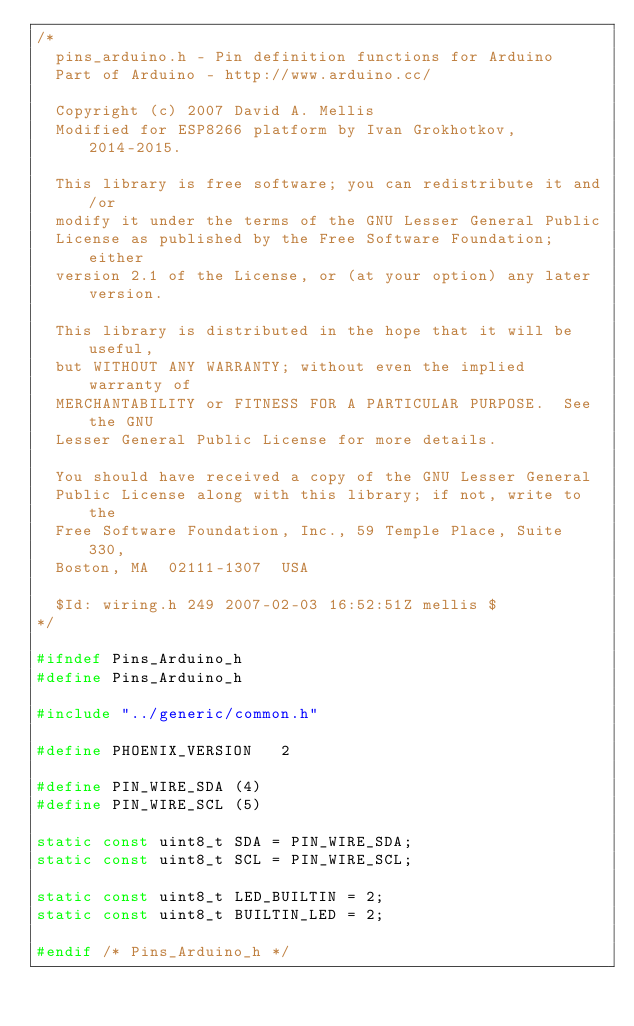Convert code to text. <code><loc_0><loc_0><loc_500><loc_500><_C_>/*
  pins_arduino.h - Pin definition functions for Arduino
  Part of Arduino - http://www.arduino.cc/

  Copyright (c) 2007 David A. Mellis
  Modified for ESP8266 platform by Ivan Grokhotkov, 2014-2015.

  This library is free software; you can redistribute it and/or
  modify it under the terms of the GNU Lesser General Public
  License as published by the Free Software Foundation; either
  version 2.1 of the License, or (at your option) any later version.

  This library is distributed in the hope that it will be useful,
  but WITHOUT ANY WARRANTY; without even the implied warranty of
  MERCHANTABILITY or FITNESS FOR A PARTICULAR PURPOSE.  See the GNU
  Lesser General Public License for more details.

  You should have received a copy of the GNU Lesser General
  Public License along with this library; if not, write to the
  Free Software Foundation, Inc., 59 Temple Place, Suite 330,
  Boston, MA  02111-1307  USA

  $Id: wiring.h 249 2007-02-03 16:52:51Z mellis $
*/

#ifndef Pins_Arduino_h
#define Pins_Arduino_h

#include "../generic/common.h"

#define PHOENIX_VERSION   2

#define PIN_WIRE_SDA (4)
#define PIN_WIRE_SCL (5)

static const uint8_t SDA = PIN_WIRE_SDA;
static const uint8_t SCL = PIN_WIRE_SCL;

static const uint8_t LED_BUILTIN = 2;
static const uint8_t BUILTIN_LED = 2;

#endif /* Pins_Arduino_h */
</code> 